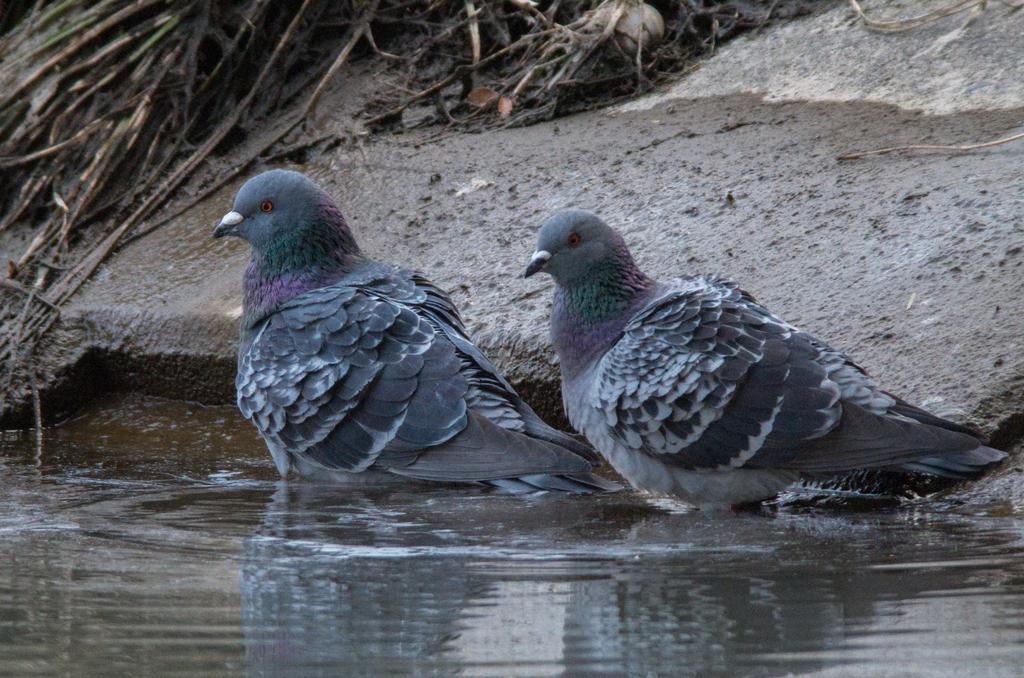Please provide a concise description of this image. In the center of the picture there are pigeons. In the foreground there is water. In the background there are waste materials and soil. 